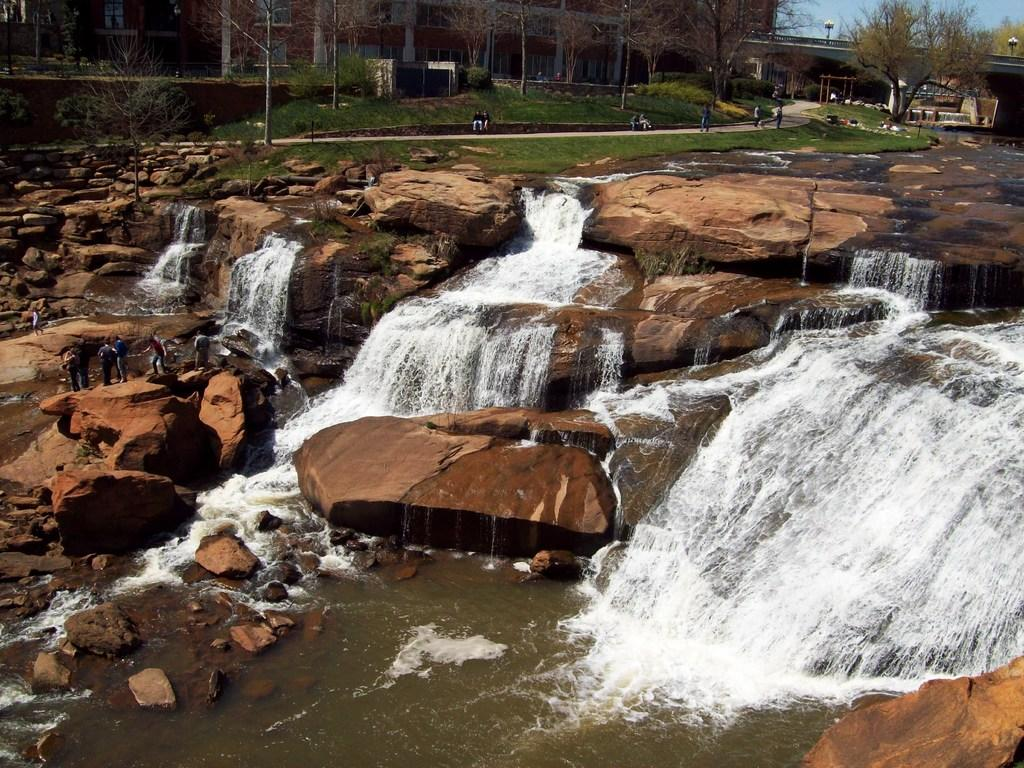What is happening with the water in the image? There is water flowing on stones in the image. What can be seen in the distance behind the stones? There are buildings, trees, and grass in the background of the image. Are there any people visible in the image? Yes, there are people in the background of the image. What activity is the fireman performing in the image? There is no fireman present in the image. Can you describe the woman's outfit in the image? There is no woman present in the image. 